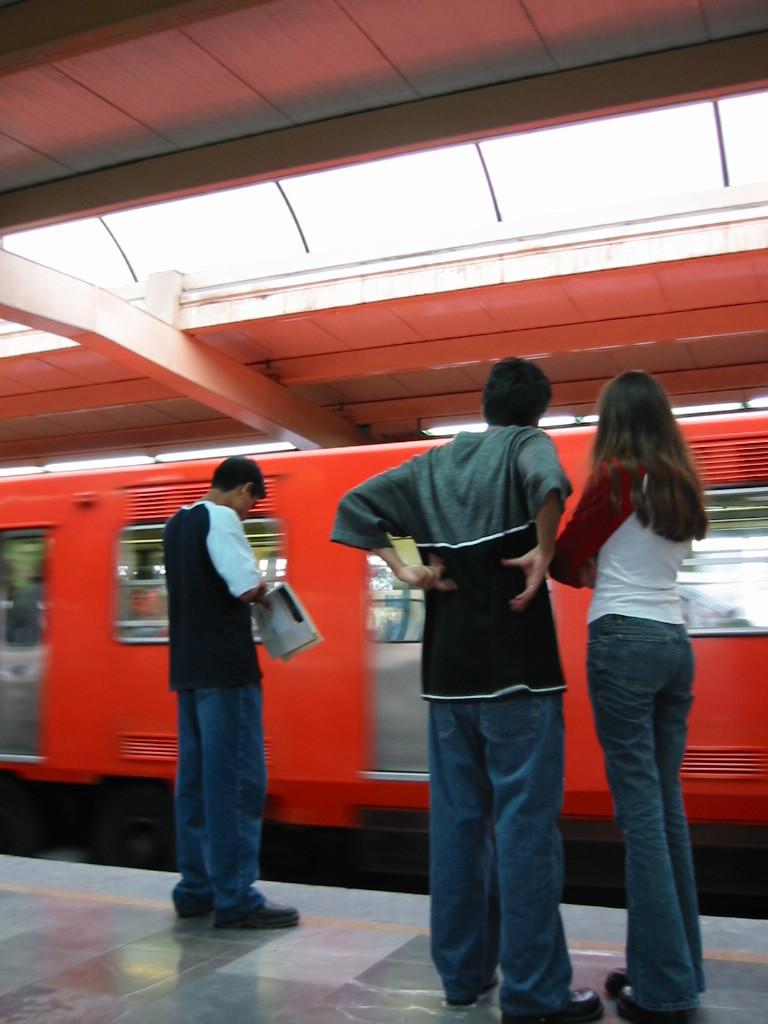How many people are in the image? There are three persons standing in the image. What is one of the persons holding in their hand? One person is holding something in their hand. What can be seen in the background of the image? There is a train visible in the background of the image. What is visible at the top of the image? There is a roof visible at the top of the image. What type of powder is being used by the person holding something in their hand? There is no indication in the image that the person is using any powder. 